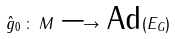<formula> <loc_0><loc_0><loc_500><loc_500>\hat { g } _ { 0 } \, \colon \, M \, \longrightarrow \, \text {Ad} ( E _ { G } )</formula> 